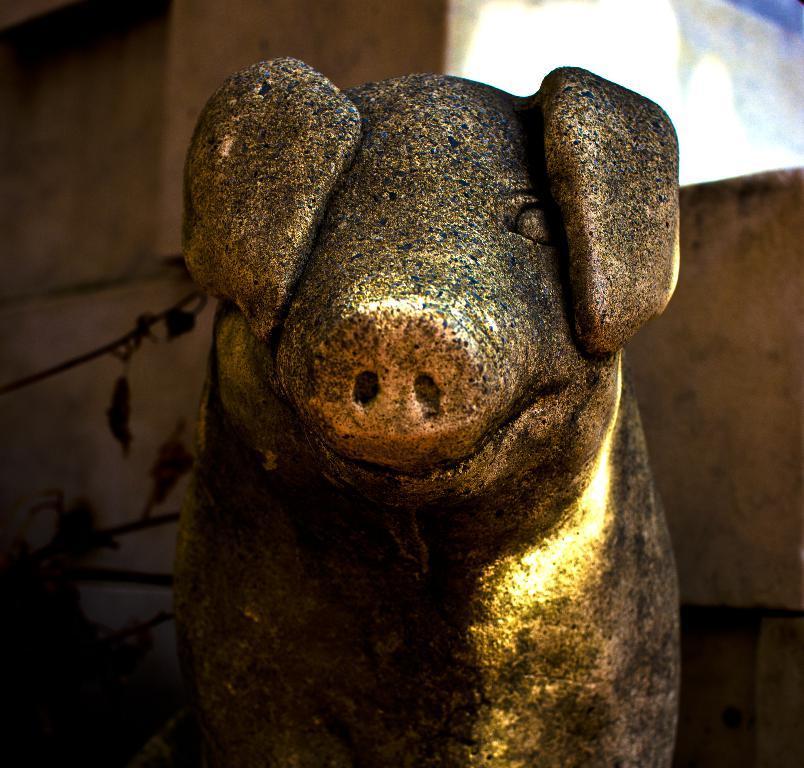In one or two sentences, can you explain what this image depicts? In the foreground of this image, there is a pig sculpture. Behind it, it seems like a wall and few leaves on the left. 